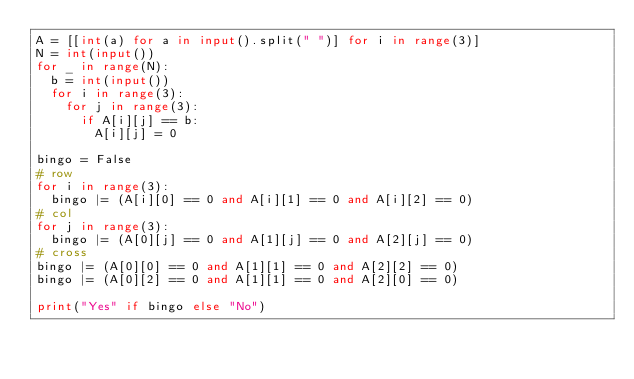Convert code to text. <code><loc_0><loc_0><loc_500><loc_500><_Python_>A = [[int(a) for a in input().split(" ")] for i in range(3)]
N = int(input())
for _ in range(N):
  b = int(input())
  for i in range(3):
    for j in range(3):
      if A[i][j] == b:
        A[i][j] = 0
        
bingo = False
# row
for i in range(3):
  bingo |= (A[i][0] == 0 and A[i][1] == 0 and A[i][2] == 0)
# col
for j in range(3):
  bingo |= (A[0][j] == 0 and A[1][j] == 0 and A[2][j] == 0)
# cross
bingo |= (A[0][0] == 0 and A[1][1] == 0 and A[2][2] == 0)
bingo |= (A[0][2] == 0 and A[1][1] == 0 and A[2][0] == 0)

print("Yes" if bingo else "No")</code> 